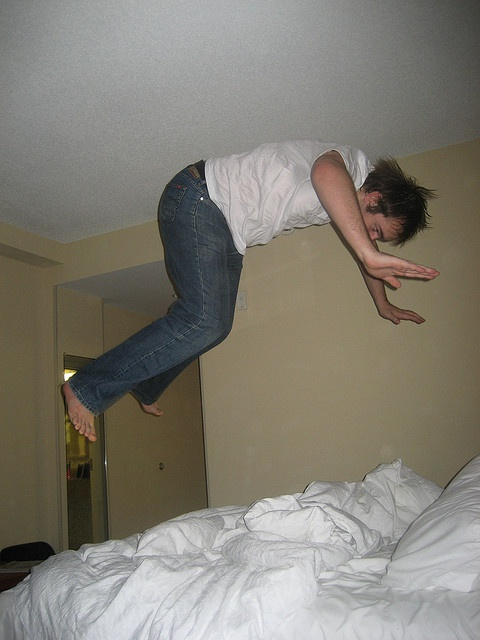Describe the objects in this image and their specific colors. I can see bed in gray, darkgray, and lightgray tones and people in gray, black, and darkgray tones in this image. 